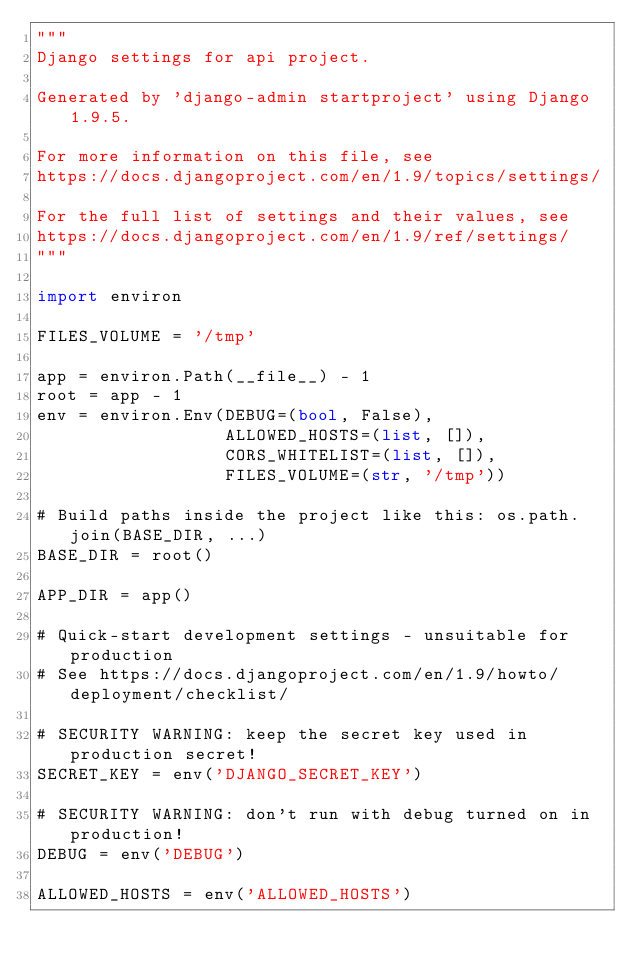<code> <loc_0><loc_0><loc_500><loc_500><_Python_>"""
Django settings for api project.

Generated by 'django-admin startproject' using Django 1.9.5.

For more information on this file, see
https://docs.djangoproject.com/en/1.9/topics/settings/

For the full list of settings and their values, see
https://docs.djangoproject.com/en/1.9/ref/settings/
"""

import environ

FILES_VOLUME = '/tmp'

app = environ.Path(__file__) - 1
root = app - 1
env = environ.Env(DEBUG=(bool, False),
                  ALLOWED_HOSTS=(list, []),
                  CORS_WHITELIST=(list, []),
                  FILES_VOLUME=(str, '/tmp'))

# Build paths inside the project like this: os.path.join(BASE_DIR, ...)
BASE_DIR = root()

APP_DIR = app()

# Quick-start development settings - unsuitable for production
# See https://docs.djangoproject.com/en/1.9/howto/deployment/checklist/

# SECURITY WARNING: keep the secret key used in production secret!
SECRET_KEY = env('DJANGO_SECRET_KEY')

# SECURITY WARNING: don't run with debug turned on in production!
DEBUG = env('DEBUG')

ALLOWED_HOSTS = env('ALLOWED_HOSTS')
</code> 